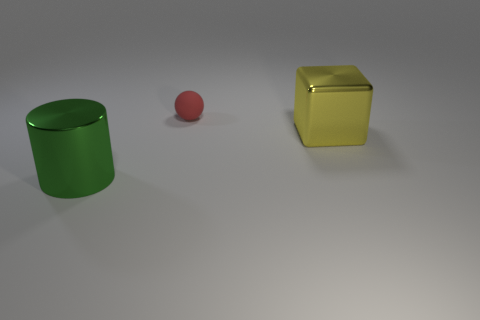There is a metal thing that is to the left of the yellow metallic cube; is it the same color as the ball?
Offer a terse response. No. Are there fewer tiny yellow cylinders than cylinders?
Ensure brevity in your answer.  Yes. Are the big object right of the green metal cylinder and the red object made of the same material?
Your answer should be compact. No. What is the material of the big thing that is to the right of the ball?
Ensure brevity in your answer.  Metal. There is a metallic thing on the left side of the big object behind the large cylinder; how big is it?
Ensure brevity in your answer.  Large. Is there a big object that has the same material as the large cylinder?
Provide a succinct answer. Yes. The thing that is in front of the big metallic object behind the thing that is on the left side of the small red sphere is what shape?
Offer a very short reply. Cylinder. Does the shiny thing that is to the left of the tiny matte thing have the same color as the shiny thing that is right of the rubber thing?
Keep it short and to the point. No. Is there anything else that is the same size as the yellow metallic thing?
Provide a succinct answer. Yes. Are there any small matte things on the left side of the green metallic cylinder?
Your answer should be very brief. No. 